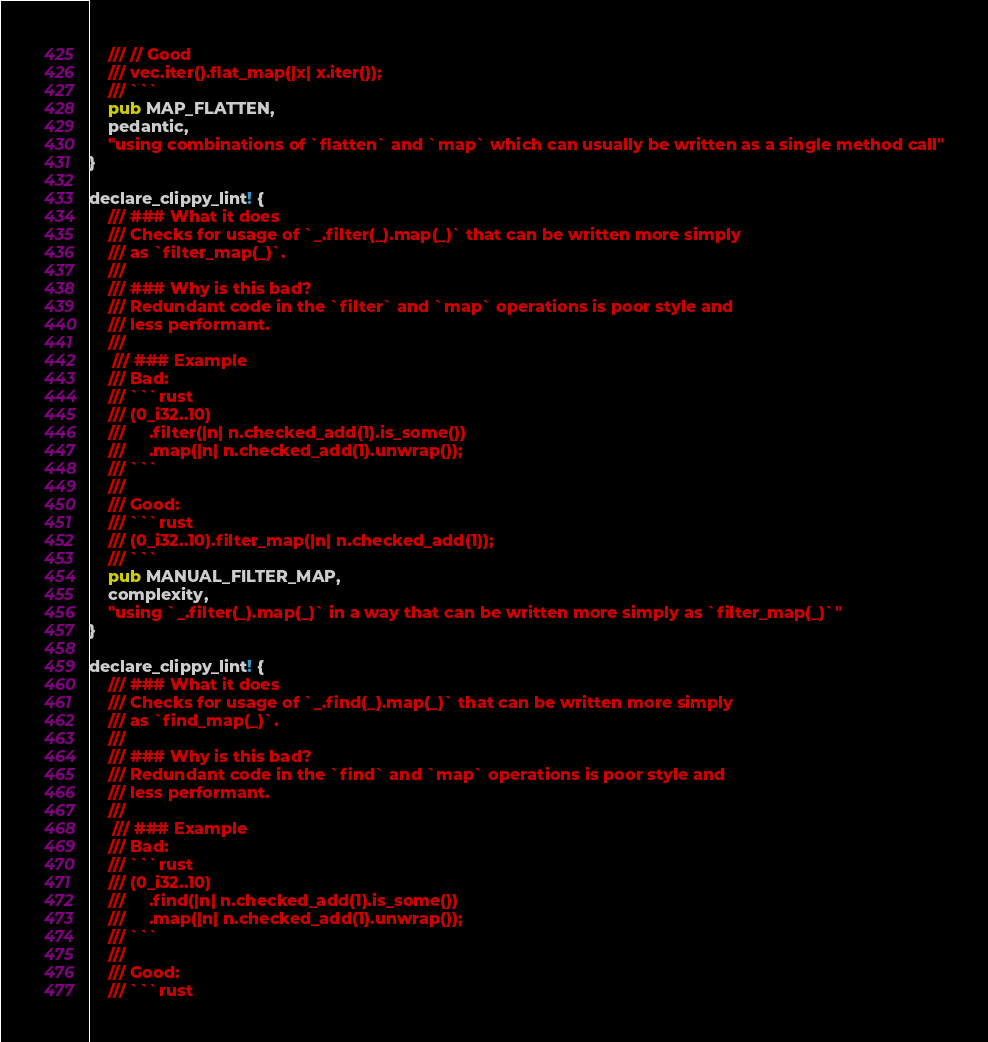Convert code to text. <code><loc_0><loc_0><loc_500><loc_500><_Rust_>    /// // Good
    /// vec.iter().flat_map(|x| x.iter());
    /// ```
    pub MAP_FLATTEN,
    pedantic,
    "using combinations of `flatten` and `map` which can usually be written as a single method call"
}

declare_clippy_lint! {
    /// ### What it does
    /// Checks for usage of `_.filter(_).map(_)` that can be written more simply
    /// as `filter_map(_)`.
    ///
    /// ### Why is this bad?
    /// Redundant code in the `filter` and `map` operations is poor style and
    /// less performant.
    ///
     /// ### Example
    /// Bad:
    /// ```rust
    /// (0_i32..10)
    ///     .filter(|n| n.checked_add(1).is_some())
    ///     .map(|n| n.checked_add(1).unwrap());
    /// ```
    ///
    /// Good:
    /// ```rust
    /// (0_i32..10).filter_map(|n| n.checked_add(1));
    /// ```
    pub MANUAL_FILTER_MAP,
    complexity,
    "using `_.filter(_).map(_)` in a way that can be written more simply as `filter_map(_)`"
}

declare_clippy_lint! {
    /// ### What it does
    /// Checks for usage of `_.find(_).map(_)` that can be written more simply
    /// as `find_map(_)`.
    ///
    /// ### Why is this bad?
    /// Redundant code in the `find` and `map` operations is poor style and
    /// less performant.
    ///
     /// ### Example
    /// Bad:
    /// ```rust
    /// (0_i32..10)
    ///     .find(|n| n.checked_add(1).is_some())
    ///     .map(|n| n.checked_add(1).unwrap());
    /// ```
    ///
    /// Good:
    /// ```rust</code> 